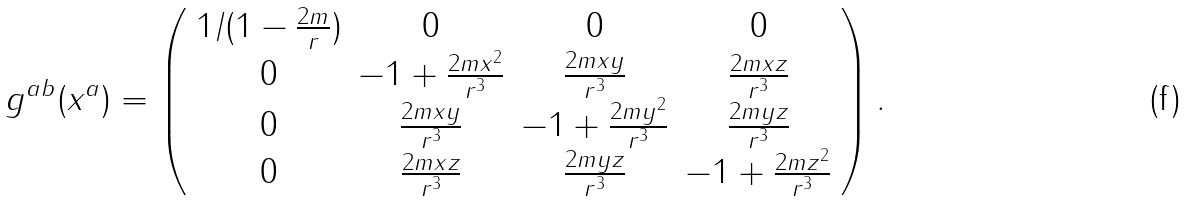Convert formula to latex. <formula><loc_0><loc_0><loc_500><loc_500>g ^ { a b } ( x ^ { a } ) = \left ( \begin{array} { c c c c } 1 / ( 1 - \frac { 2 m } { r } ) & 0 & 0 & 0 \\ 0 & - 1 + \frac { 2 m x ^ { 2 } } { r ^ { 3 } } & \frac { 2 m x y } { r ^ { 3 } } & \frac { 2 m x z } { r ^ { 3 } } \\ 0 & \frac { 2 m x y } { r ^ { 3 } } & - 1 + \frac { 2 m y ^ { 2 } } { r ^ { 3 } } & \frac { 2 m y z } { r ^ { 3 } } \\ 0 & \frac { 2 m x z } { r ^ { 3 } } & \frac { 2 m y z } { r ^ { 3 } } & - 1 + \frac { 2 m z ^ { 2 } } { r ^ { 3 } } \end{array} \right ) .</formula> 